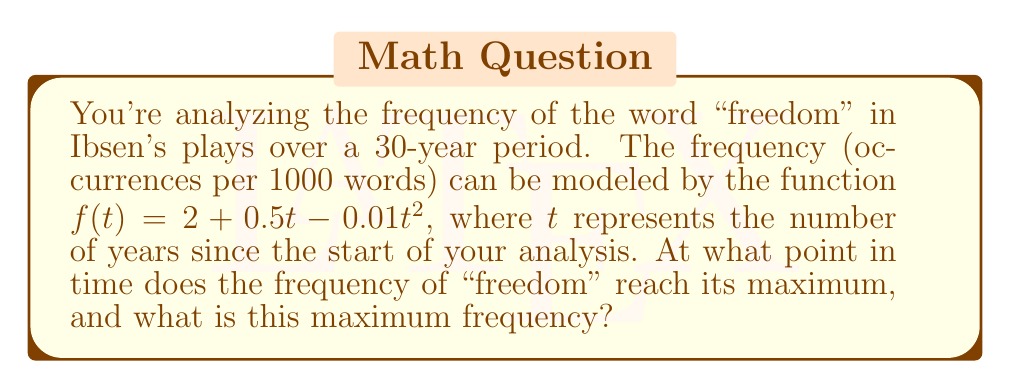Can you solve this math problem? To solve this problem, we need to follow these steps:

1) The function $f(t) = 2 + 0.5t - 0.01t^2$ represents a quadratic equation. The maximum or minimum of a quadratic function occurs at the vertex of the parabola.

2) To find the vertex, we can use the formula: $t = -\frac{b}{2a}$, where $a$ and $b$ are the coefficients of the quadratic equation in the form $at^2 + bt + c$.

3) In our case, $a = -0.01$ and $b = 0.5$. Let's substitute these values:

   $t = -\frac{0.5}{2(-0.01)} = -\frac{0.5}{-0.02} = 25$

4) This means the maximum frequency occurs 25 years after the start of our analysis.

5) To find the maximum frequency, we need to substitute $t = 25$ into our original function:

   $f(25) = 2 + 0.5(25) - 0.01(25)^2$
          $= 2 + 12.5 - 0.01(625)$
          $= 14.5 - 6.25$
          $= 8.25$

Therefore, the maximum frequency is 8.25 occurrences per 1000 words.
Answer: The frequency of "freedom" reaches its maximum after 25 years, with a peak frequency of 8.25 occurrences per 1000 words. 